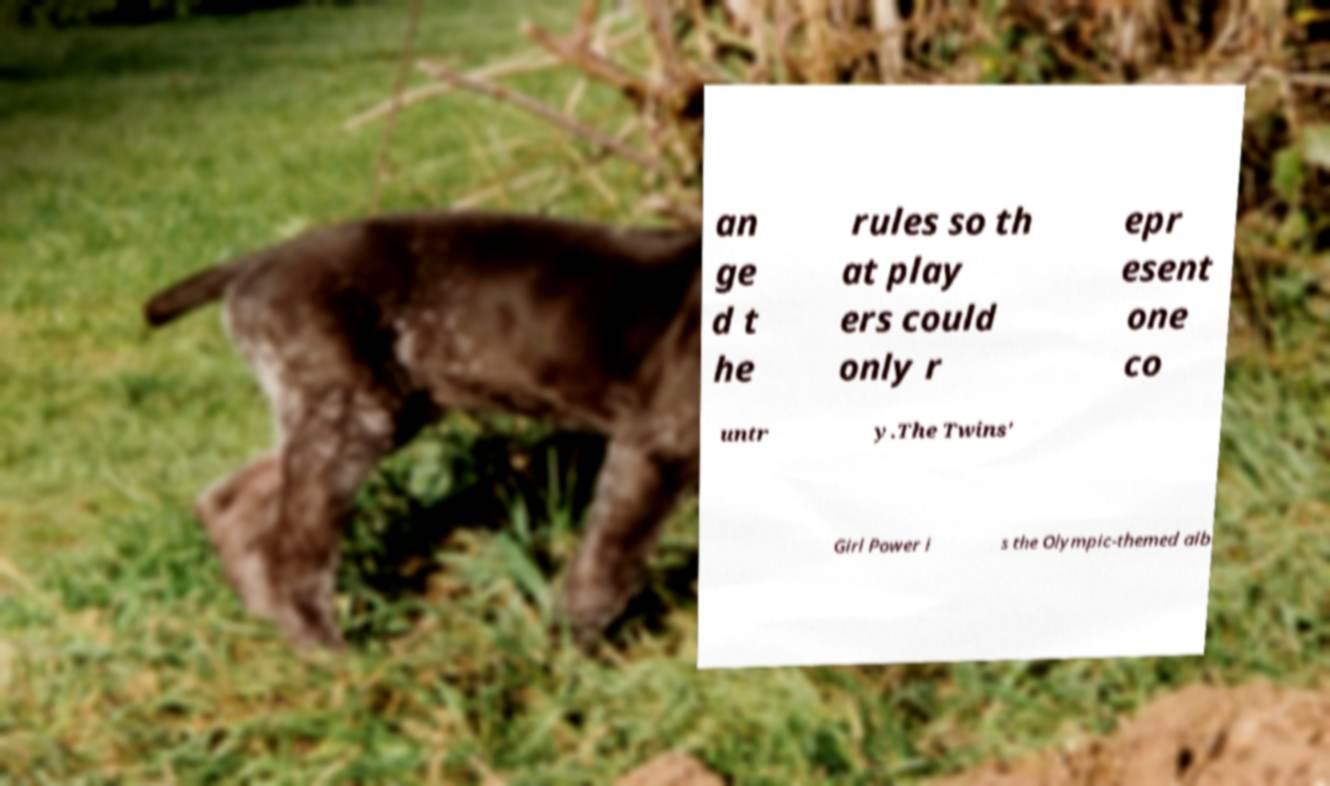I need the written content from this picture converted into text. Can you do that? an ge d t he rules so th at play ers could only r epr esent one co untr y.The Twins' Girl Power i s the Olympic-themed alb 